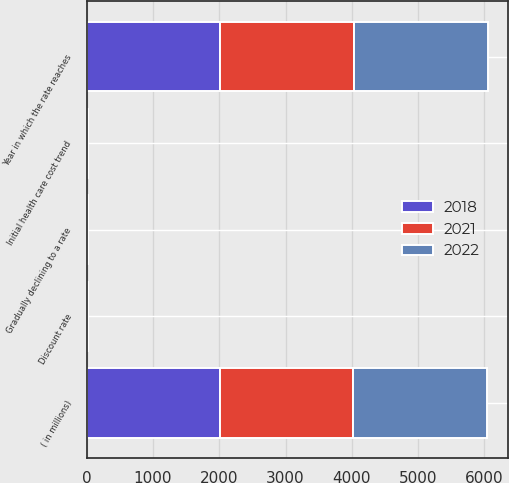<chart> <loc_0><loc_0><loc_500><loc_500><stacked_bar_chart><ecel><fcel>( in millions)<fcel>Discount rate<fcel>Initial health care cost trend<fcel>Gradually declining to a rate<fcel>Year in which the rate reaches<nl><fcel>2022<fcel>2014<fcel>5.03<fcel>7.33<fcel>5<fcel>2022<nl><fcel>2021<fcel>2013<fcel>4.02<fcel>7.67<fcel>5<fcel>2021<nl><fcel>2018<fcel>2012<fcel>4.94<fcel>8<fcel>5<fcel>2018<nl></chart> 